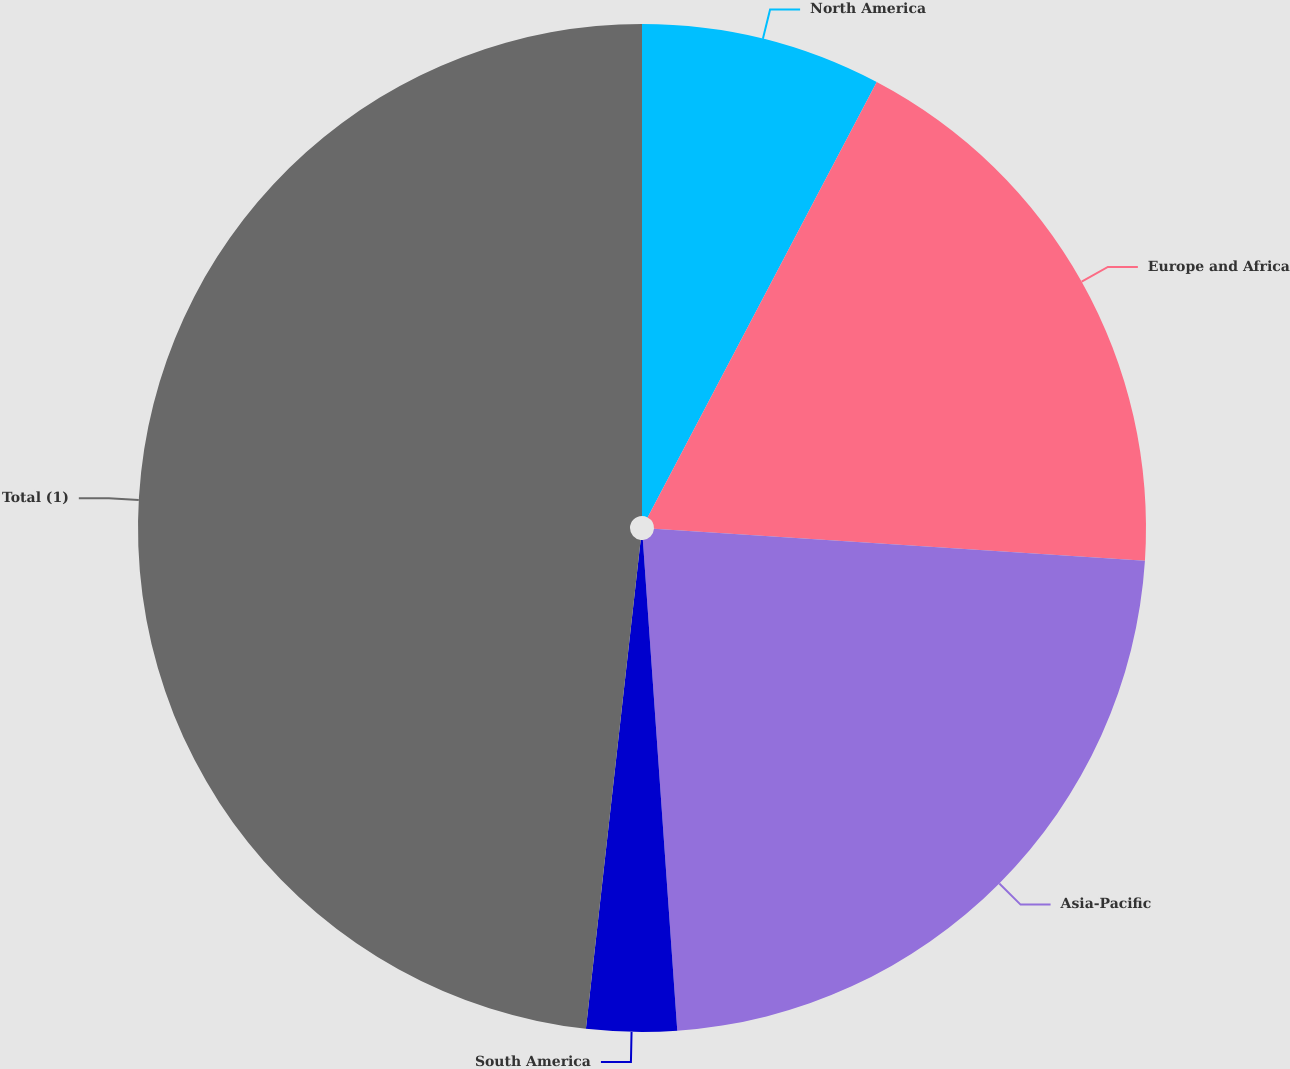Convert chart. <chart><loc_0><loc_0><loc_500><loc_500><pie_chart><fcel>North America<fcel>Europe and Africa<fcel>Asia-Pacific<fcel>South America<fcel>Total (1)<nl><fcel>7.71%<fcel>18.32%<fcel>22.85%<fcel>2.89%<fcel>48.22%<nl></chart> 